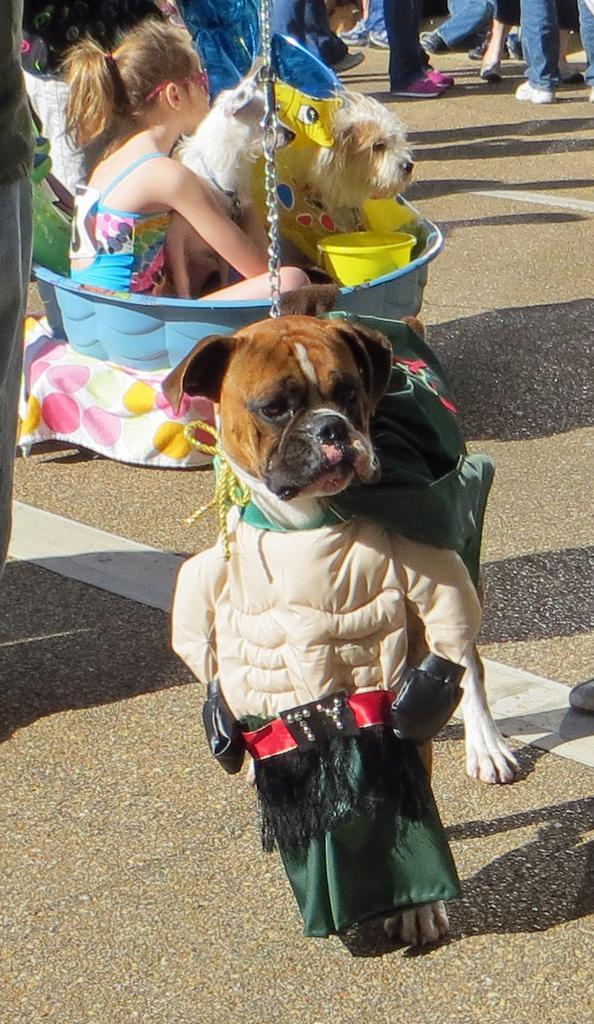Please provide a concise description of this image. This image is clicked on the roads. In the front, there is a dog which is dressed up. In the background, there is a tub in which a dog and girl are sitting. At the bottom, there is a road. In the background, there are people walking. 